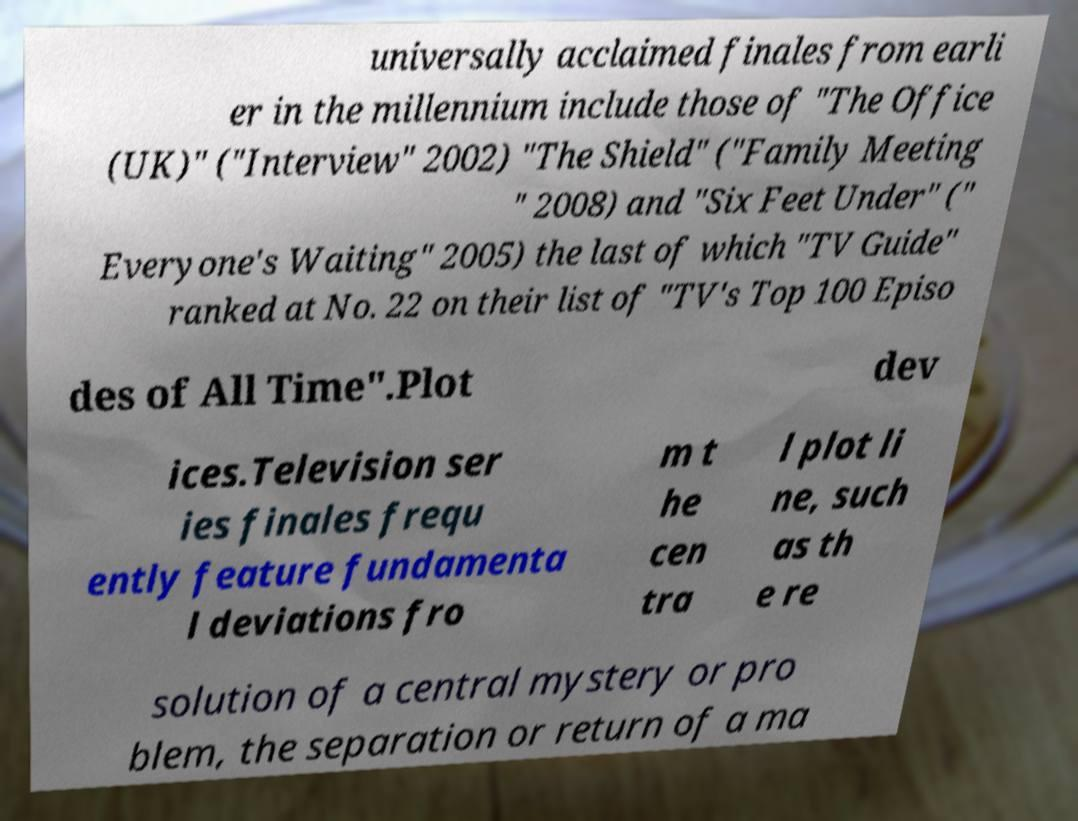I need the written content from this picture converted into text. Can you do that? universally acclaimed finales from earli er in the millennium include those of "The Office (UK)" ("Interview" 2002) "The Shield" ("Family Meeting " 2008) and "Six Feet Under" (" Everyone's Waiting" 2005) the last of which "TV Guide" ranked at No. 22 on their list of "TV's Top 100 Episo des of All Time".Plot dev ices.Television ser ies finales frequ ently feature fundamenta l deviations fro m t he cen tra l plot li ne, such as th e re solution of a central mystery or pro blem, the separation or return of a ma 